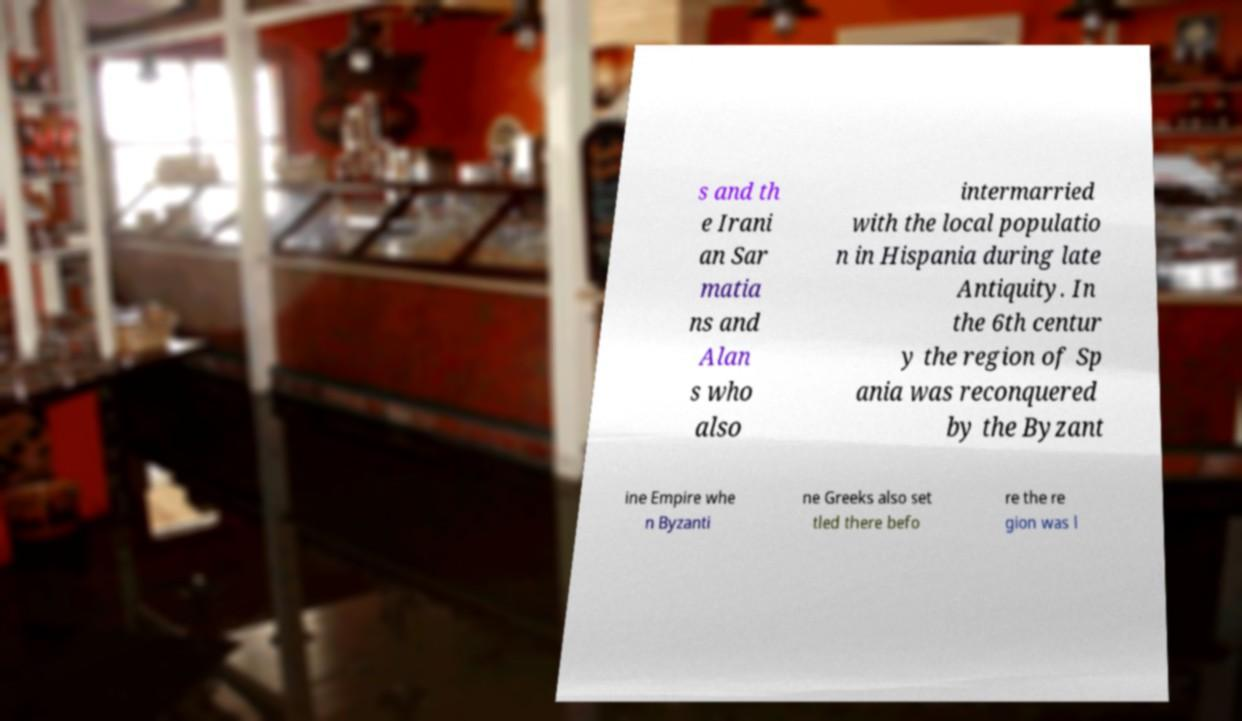What messages or text are displayed in this image? I need them in a readable, typed format. s and th e Irani an Sar matia ns and Alan s who also intermarried with the local populatio n in Hispania during late Antiquity. In the 6th centur y the region of Sp ania was reconquered by the Byzant ine Empire whe n Byzanti ne Greeks also set tled there befo re the re gion was l 